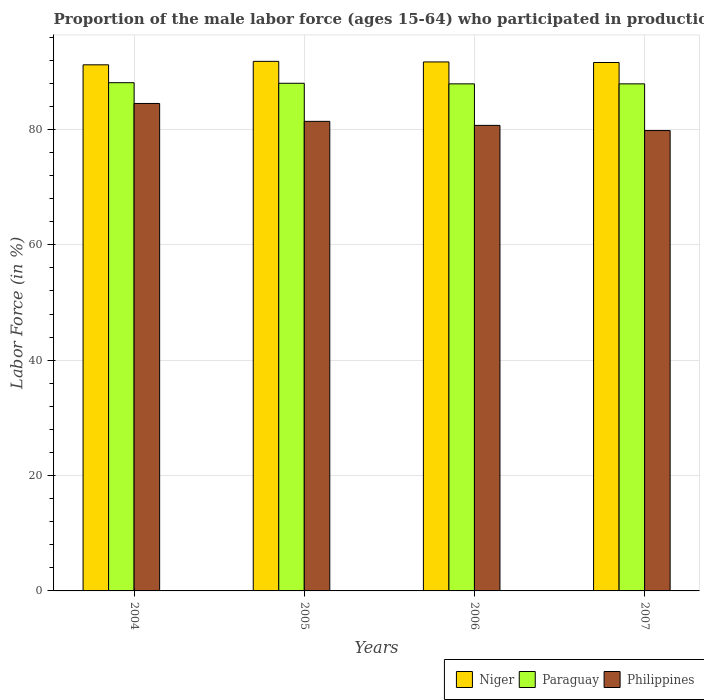How many different coloured bars are there?
Your answer should be compact. 3. How many groups of bars are there?
Your answer should be very brief. 4. Are the number of bars on each tick of the X-axis equal?
Ensure brevity in your answer.  Yes. How many bars are there on the 1st tick from the left?
Your response must be concise. 3. How many bars are there on the 1st tick from the right?
Give a very brief answer. 3. What is the proportion of the male labor force who participated in production in Philippines in 2005?
Your answer should be compact. 81.4. Across all years, what is the maximum proportion of the male labor force who participated in production in Paraguay?
Make the answer very short. 88.1. Across all years, what is the minimum proportion of the male labor force who participated in production in Philippines?
Provide a short and direct response. 79.8. In which year was the proportion of the male labor force who participated in production in Niger maximum?
Ensure brevity in your answer.  2005. What is the total proportion of the male labor force who participated in production in Philippines in the graph?
Provide a succinct answer. 326.4. What is the difference between the proportion of the male labor force who participated in production in Philippines in 2005 and that in 2007?
Make the answer very short. 1.6. What is the difference between the proportion of the male labor force who participated in production in Niger in 2005 and the proportion of the male labor force who participated in production in Philippines in 2004?
Offer a very short reply. 7.3. What is the average proportion of the male labor force who participated in production in Paraguay per year?
Provide a short and direct response. 87.98. In the year 2007, what is the difference between the proportion of the male labor force who participated in production in Niger and proportion of the male labor force who participated in production in Philippines?
Keep it short and to the point. 11.8. In how many years, is the proportion of the male labor force who participated in production in Niger greater than 4 %?
Your response must be concise. 4. What is the ratio of the proportion of the male labor force who participated in production in Paraguay in 2004 to that in 2005?
Offer a terse response. 1. What is the difference between the highest and the second highest proportion of the male labor force who participated in production in Paraguay?
Your answer should be very brief. 0.1. What is the difference between the highest and the lowest proportion of the male labor force who participated in production in Niger?
Offer a very short reply. 0.6. In how many years, is the proportion of the male labor force who participated in production in Paraguay greater than the average proportion of the male labor force who participated in production in Paraguay taken over all years?
Your answer should be compact. 2. Is the sum of the proportion of the male labor force who participated in production in Paraguay in 2005 and 2007 greater than the maximum proportion of the male labor force who participated in production in Niger across all years?
Your answer should be very brief. Yes. What does the 3rd bar from the left in 2005 represents?
Your answer should be very brief. Philippines. What does the 2nd bar from the right in 2004 represents?
Offer a terse response. Paraguay. Is it the case that in every year, the sum of the proportion of the male labor force who participated in production in Philippines and proportion of the male labor force who participated in production in Paraguay is greater than the proportion of the male labor force who participated in production in Niger?
Ensure brevity in your answer.  Yes. How many bars are there?
Offer a very short reply. 12. Are all the bars in the graph horizontal?
Offer a terse response. No. What is the difference between two consecutive major ticks on the Y-axis?
Your answer should be very brief. 20. Does the graph contain grids?
Provide a short and direct response. Yes. Where does the legend appear in the graph?
Offer a terse response. Bottom right. How many legend labels are there?
Your response must be concise. 3. What is the title of the graph?
Your response must be concise. Proportion of the male labor force (ages 15-64) who participated in production. What is the Labor Force (in %) of Niger in 2004?
Provide a short and direct response. 91.2. What is the Labor Force (in %) of Paraguay in 2004?
Keep it short and to the point. 88.1. What is the Labor Force (in %) of Philippines in 2004?
Your answer should be compact. 84.5. What is the Labor Force (in %) in Niger in 2005?
Your response must be concise. 91.8. What is the Labor Force (in %) of Philippines in 2005?
Ensure brevity in your answer.  81.4. What is the Labor Force (in %) in Niger in 2006?
Keep it short and to the point. 91.7. What is the Labor Force (in %) of Paraguay in 2006?
Keep it short and to the point. 87.9. What is the Labor Force (in %) of Philippines in 2006?
Keep it short and to the point. 80.7. What is the Labor Force (in %) of Niger in 2007?
Ensure brevity in your answer.  91.6. What is the Labor Force (in %) in Paraguay in 2007?
Your answer should be compact. 87.9. What is the Labor Force (in %) in Philippines in 2007?
Provide a succinct answer. 79.8. Across all years, what is the maximum Labor Force (in %) in Niger?
Your answer should be compact. 91.8. Across all years, what is the maximum Labor Force (in %) of Paraguay?
Make the answer very short. 88.1. Across all years, what is the maximum Labor Force (in %) of Philippines?
Keep it short and to the point. 84.5. Across all years, what is the minimum Labor Force (in %) of Niger?
Your answer should be compact. 91.2. Across all years, what is the minimum Labor Force (in %) in Paraguay?
Your response must be concise. 87.9. Across all years, what is the minimum Labor Force (in %) in Philippines?
Your answer should be compact. 79.8. What is the total Labor Force (in %) in Niger in the graph?
Your answer should be very brief. 366.3. What is the total Labor Force (in %) in Paraguay in the graph?
Offer a terse response. 351.9. What is the total Labor Force (in %) in Philippines in the graph?
Your answer should be compact. 326.4. What is the difference between the Labor Force (in %) of Niger in 2004 and that in 2005?
Provide a succinct answer. -0.6. What is the difference between the Labor Force (in %) in Paraguay in 2004 and that in 2005?
Keep it short and to the point. 0.1. What is the difference between the Labor Force (in %) in Philippines in 2004 and that in 2006?
Your answer should be very brief. 3.8. What is the difference between the Labor Force (in %) in Philippines in 2004 and that in 2007?
Provide a succinct answer. 4.7. What is the difference between the Labor Force (in %) in Philippines in 2005 and that in 2006?
Offer a terse response. 0.7. What is the difference between the Labor Force (in %) in Philippines in 2005 and that in 2007?
Provide a short and direct response. 1.6. What is the difference between the Labor Force (in %) of Niger in 2006 and that in 2007?
Provide a succinct answer. 0.1. What is the difference between the Labor Force (in %) in Paraguay in 2006 and that in 2007?
Keep it short and to the point. 0. What is the difference between the Labor Force (in %) in Paraguay in 2004 and the Labor Force (in %) in Philippines in 2005?
Your answer should be compact. 6.7. What is the difference between the Labor Force (in %) in Niger in 2004 and the Labor Force (in %) in Paraguay in 2006?
Keep it short and to the point. 3.3. What is the difference between the Labor Force (in %) in Niger in 2004 and the Labor Force (in %) in Philippines in 2007?
Keep it short and to the point. 11.4. What is the difference between the Labor Force (in %) of Paraguay in 2004 and the Labor Force (in %) of Philippines in 2007?
Your answer should be very brief. 8.3. What is the difference between the Labor Force (in %) in Niger in 2005 and the Labor Force (in %) in Paraguay in 2006?
Ensure brevity in your answer.  3.9. What is the difference between the Labor Force (in %) in Niger in 2005 and the Labor Force (in %) in Philippines in 2006?
Ensure brevity in your answer.  11.1. What is the difference between the Labor Force (in %) of Niger in 2006 and the Labor Force (in %) of Philippines in 2007?
Offer a very short reply. 11.9. What is the difference between the Labor Force (in %) in Paraguay in 2006 and the Labor Force (in %) in Philippines in 2007?
Your answer should be compact. 8.1. What is the average Labor Force (in %) in Niger per year?
Ensure brevity in your answer.  91.58. What is the average Labor Force (in %) in Paraguay per year?
Ensure brevity in your answer.  87.97. What is the average Labor Force (in %) in Philippines per year?
Keep it short and to the point. 81.6. In the year 2004, what is the difference between the Labor Force (in %) in Niger and Labor Force (in %) in Philippines?
Offer a terse response. 6.7. In the year 2005, what is the difference between the Labor Force (in %) of Niger and Labor Force (in %) of Paraguay?
Your response must be concise. 3.8. In the year 2005, what is the difference between the Labor Force (in %) of Niger and Labor Force (in %) of Philippines?
Your answer should be compact. 10.4. In the year 2005, what is the difference between the Labor Force (in %) of Paraguay and Labor Force (in %) of Philippines?
Your response must be concise. 6.6. In the year 2006, what is the difference between the Labor Force (in %) of Niger and Labor Force (in %) of Paraguay?
Give a very brief answer. 3.8. In the year 2006, what is the difference between the Labor Force (in %) in Paraguay and Labor Force (in %) in Philippines?
Ensure brevity in your answer.  7.2. In the year 2007, what is the difference between the Labor Force (in %) of Niger and Labor Force (in %) of Paraguay?
Offer a terse response. 3.7. In the year 2007, what is the difference between the Labor Force (in %) in Niger and Labor Force (in %) in Philippines?
Make the answer very short. 11.8. What is the ratio of the Labor Force (in %) of Philippines in 2004 to that in 2005?
Provide a succinct answer. 1.04. What is the ratio of the Labor Force (in %) in Philippines in 2004 to that in 2006?
Provide a succinct answer. 1.05. What is the ratio of the Labor Force (in %) in Paraguay in 2004 to that in 2007?
Offer a terse response. 1. What is the ratio of the Labor Force (in %) in Philippines in 2004 to that in 2007?
Your answer should be very brief. 1.06. What is the ratio of the Labor Force (in %) in Niger in 2005 to that in 2006?
Provide a succinct answer. 1. What is the ratio of the Labor Force (in %) in Paraguay in 2005 to that in 2006?
Provide a succinct answer. 1. What is the ratio of the Labor Force (in %) in Philippines in 2005 to that in 2006?
Keep it short and to the point. 1.01. What is the ratio of the Labor Force (in %) in Niger in 2005 to that in 2007?
Give a very brief answer. 1. What is the ratio of the Labor Force (in %) of Philippines in 2005 to that in 2007?
Keep it short and to the point. 1.02. What is the ratio of the Labor Force (in %) of Paraguay in 2006 to that in 2007?
Make the answer very short. 1. What is the ratio of the Labor Force (in %) of Philippines in 2006 to that in 2007?
Offer a very short reply. 1.01. What is the difference between the highest and the second highest Labor Force (in %) of Niger?
Your response must be concise. 0.1. What is the difference between the highest and the second highest Labor Force (in %) of Paraguay?
Offer a very short reply. 0.1. What is the difference between the highest and the lowest Labor Force (in %) of Philippines?
Make the answer very short. 4.7. 